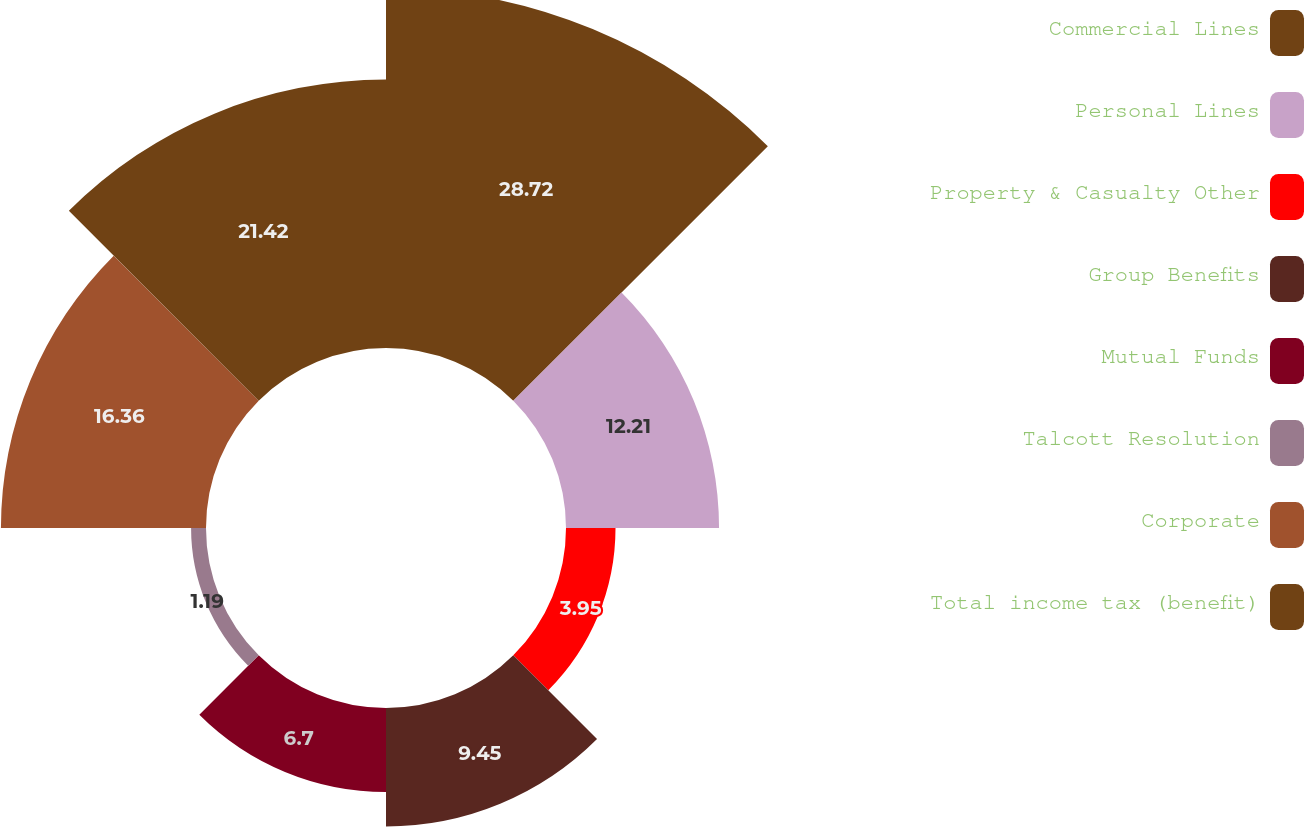Convert chart to OTSL. <chart><loc_0><loc_0><loc_500><loc_500><pie_chart><fcel>Commercial Lines<fcel>Personal Lines<fcel>Property & Casualty Other<fcel>Group Benefits<fcel>Mutual Funds<fcel>Talcott Resolution<fcel>Corporate<fcel>Total income tax (benefit)<nl><fcel>28.72%<fcel>12.21%<fcel>3.95%<fcel>9.45%<fcel>6.7%<fcel>1.19%<fcel>16.36%<fcel>21.42%<nl></chart> 